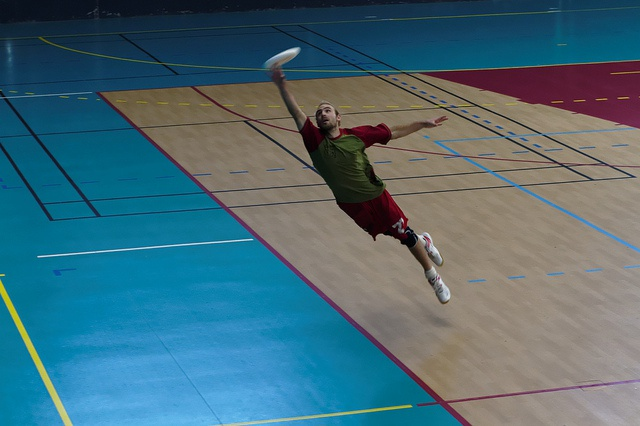Describe the objects in this image and their specific colors. I can see people in black, maroon, and gray tones and frisbee in black, gray, darkgray, and blue tones in this image. 